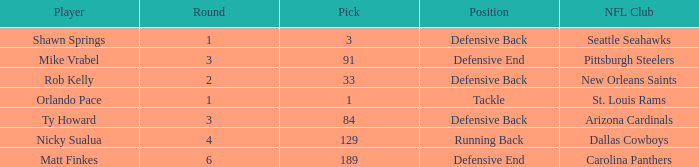What lowest round has orlando pace as the player? 1.0. 